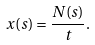<formula> <loc_0><loc_0><loc_500><loc_500>x ( s ) = \frac { N ( s ) } { t } .</formula> 